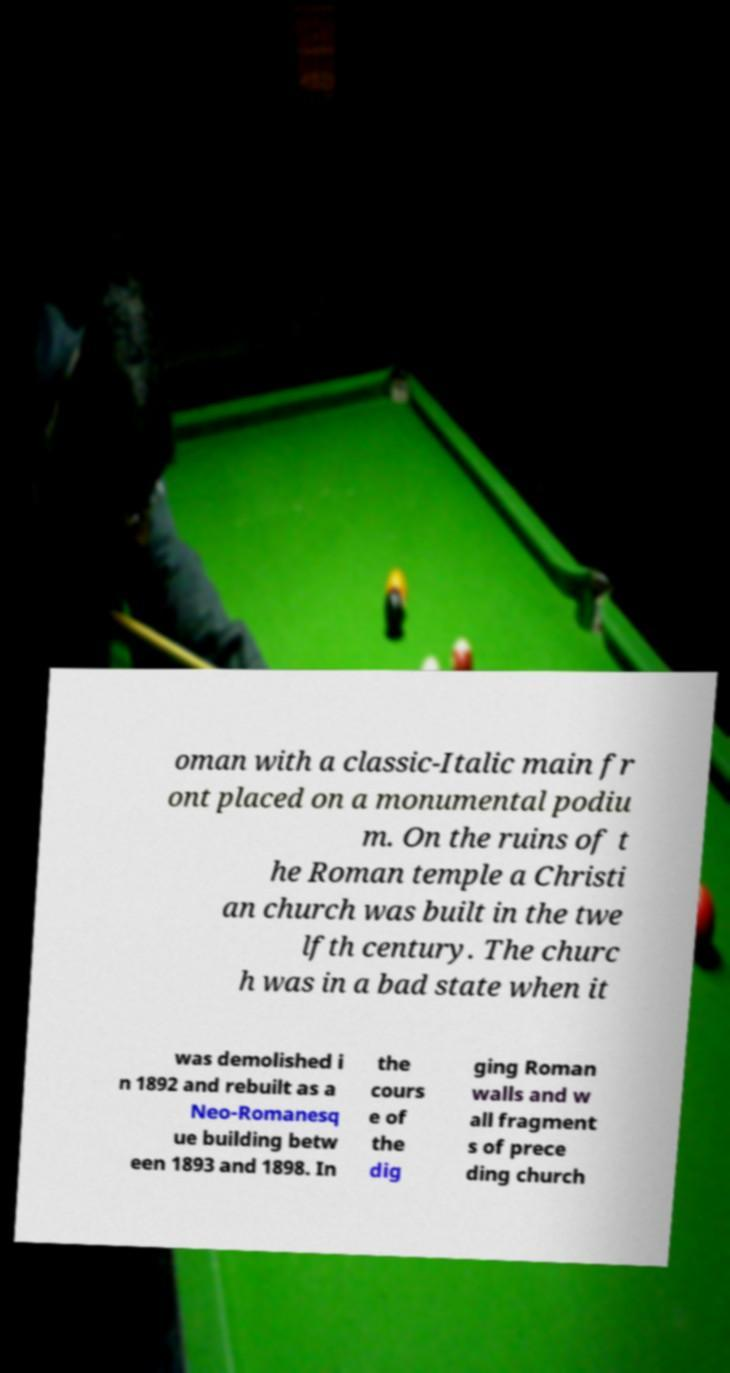Please identify and transcribe the text found in this image. oman with a classic-Italic main fr ont placed on a monumental podiu m. On the ruins of t he Roman temple a Christi an church was built in the twe lfth century. The churc h was in a bad state when it was demolished i n 1892 and rebuilt as a Neo-Romanesq ue building betw een 1893 and 1898. In the cours e of the dig ging Roman walls and w all fragment s of prece ding church 